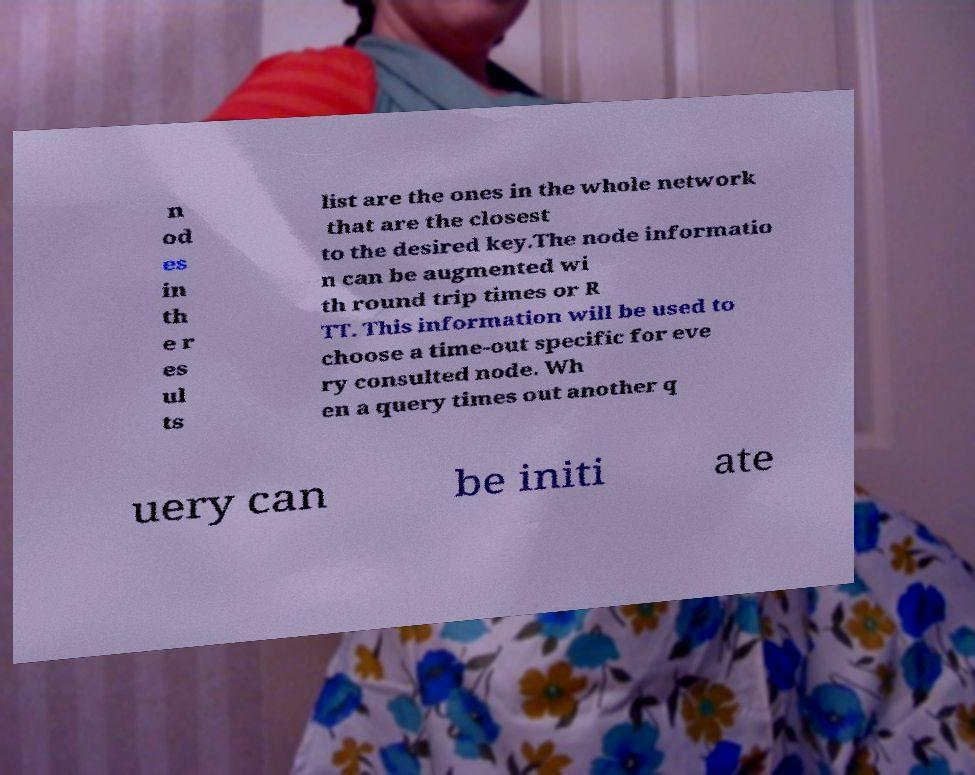What messages or text are displayed in this image? I need them in a readable, typed format. n od es in th e r es ul ts list are the ones in the whole network that are the closest to the desired key.The node informatio n can be augmented wi th round trip times or R TT. This information will be used to choose a time-out specific for eve ry consulted node. Wh en a query times out another q uery can be initi ate 